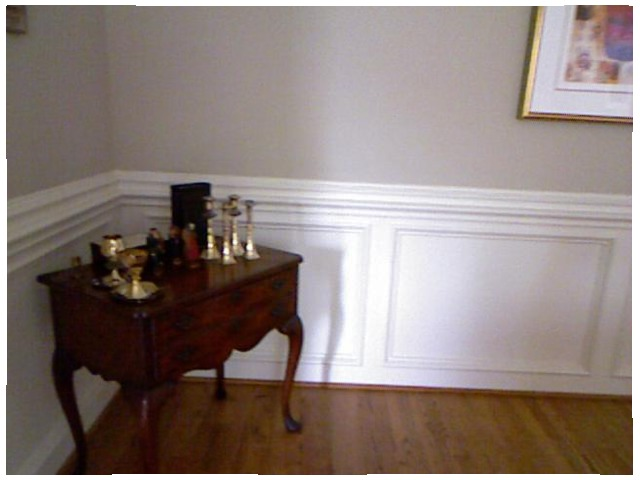<image>
Can you confirm if the table is on the wall? No. The table is not positioned on the wall. They may be near each other, but the table is not supported by or resting on top of the wall. 